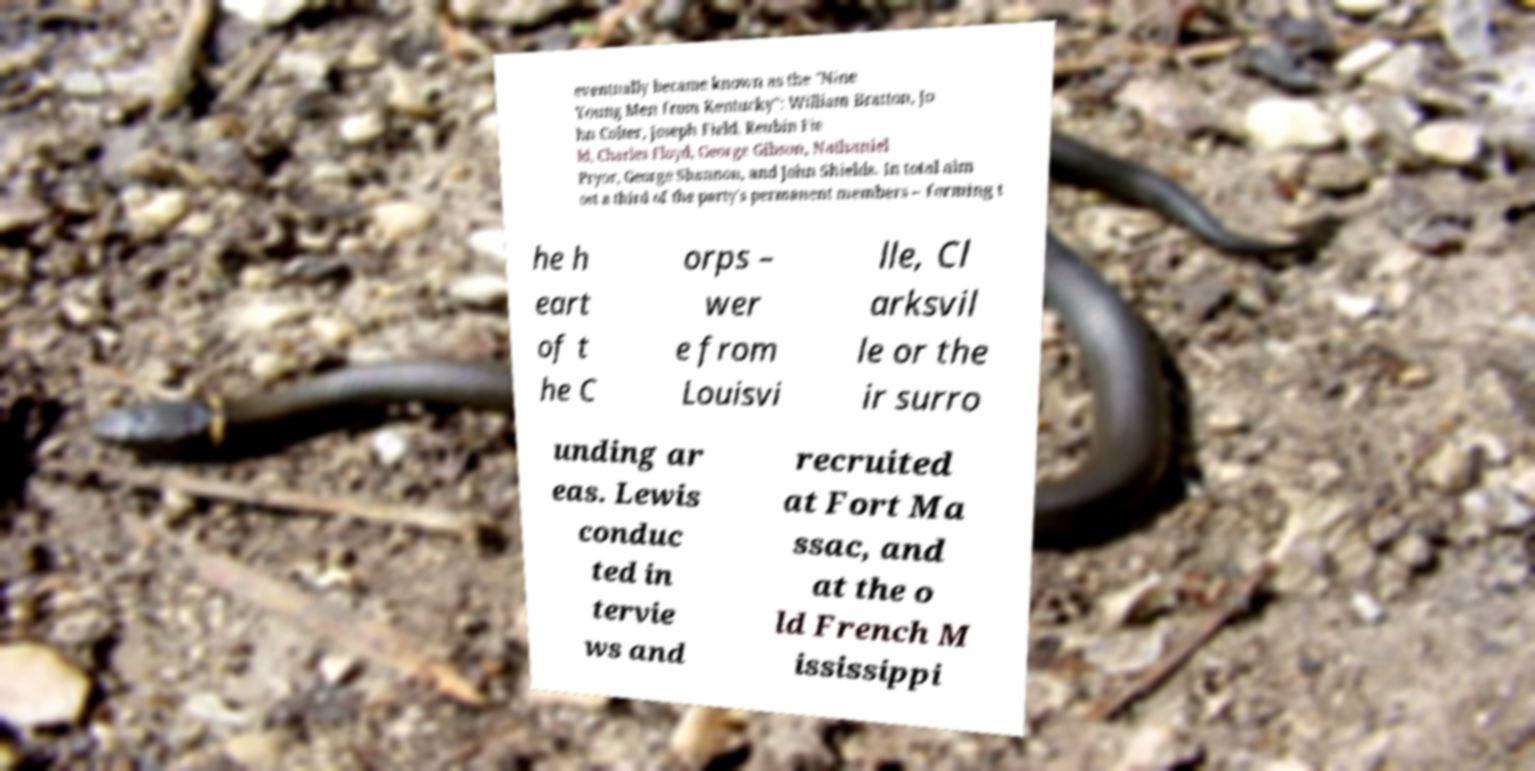Can you accurately transcribe the text from the provided image for me? eventually became known as the "Nine Young Men from Kentucky": William Bratton, Jo hn Colter, Joseph Field, Reubin Fie ld, Charles Floyd, George Gibson, Nathaniel Pryor, George Shannon, and John Shields. In total alm ost a third of the party's permanent members – forming t he h eart of t he C orps – wer e from Louisvi lle, Cl arksvil le or the ir surro unding ar eas. Lewis conduc ted in tervie ws and recruited at Fort Ma ssac, and at the o ld French M ississippi 